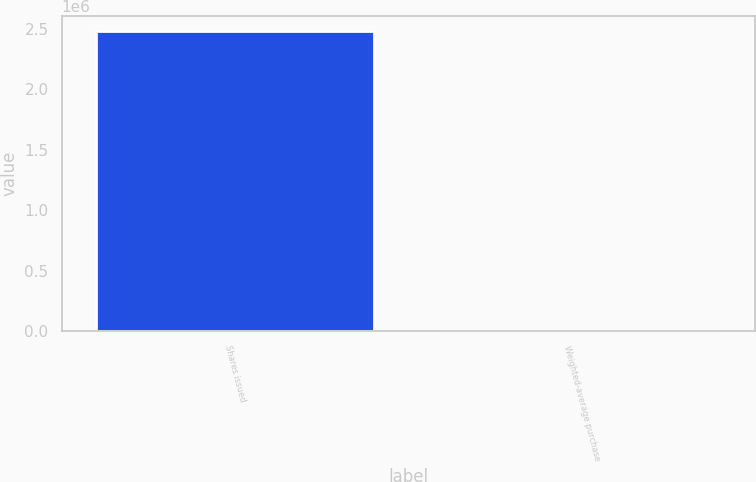Convert chart. <chart><loc_0><loc_0><loc_500><loc_500><bar_chart><fcel>Shares issued<fcel>Weighted-average purchase<nl><fcel>2.48337e+06<fcel>10.55<nl></chart> 